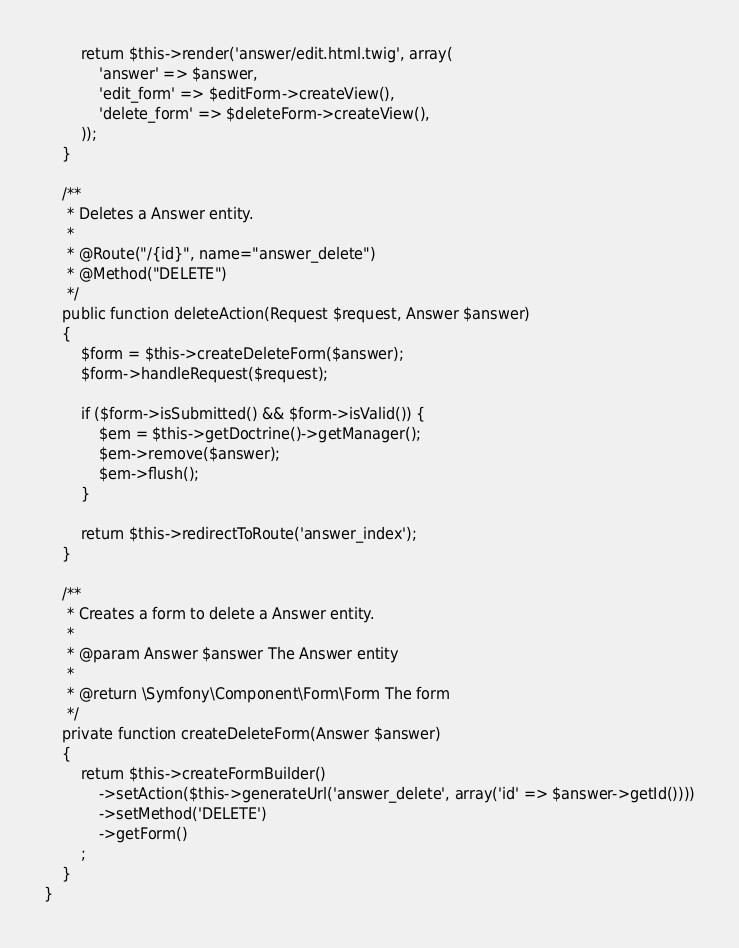<code> <loc_0><loc_0><loc_500><loc_500><_PHP_>        return $this->render('answer/edit.html.twig', array(
            'answer' => $answer,
            'edit_form' => $editForm->createView(),
            'delete_form' => $deleteForm->createView(),
        ));
    }

    /**
     * Deletes a Answer entity.
     *
     * @Route("/{id}", name="answer_delete")
     * @Method("DELETE")
     */
    public function deleteAction(Request $request, Answer $answer)
    {
        $form = $this->createDeleteForm($answer);
        $form->handleRequest($request);

        if ($form->isSubmitted() && $form->isValid()) {
            $em = $this->getDoctrine()->getManager();
            $em->remove($answer);
            $em->flush();
        }

        return $this->redirectToRoute('answer_index');
    }

    /**
     * Creates a form to delete a Answer entity.
     *
     * @param Answer $answer The Answer entity
     *
     * @return \Symfony\Component\Form\Form The form
     */
    private function createDeleteForm(Answer $answer)
    {
        return $this->createFormBuilder()
            ->setAction($this->generateUrl('answer_delete', array('id' => $answer->getId())))
            ->setMethod('DELETE')
            ->getForm()
        ;
    }
}
</code> 